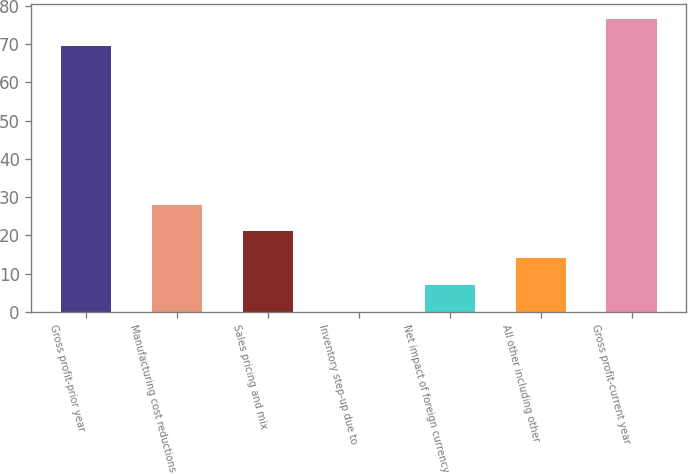Convert chart. <chart><loc_0><loc_0><loc_500><loc_500><bar_chart><fcel>Gross profit-prior year<fcel>Manufacturing cost reductions<fcel>Sales pricing and mix<fcel>Inventory step-up due to<fcel>Net impact of foreign currency<fcel>All other including other<fcel>Gross profit-current year<nl><fcel>69.6<fcel>28.1<fcel>21.1<fcel>0.1<fcel>7.1<fcel>14.1<fcel>76.6<nl></chart> 